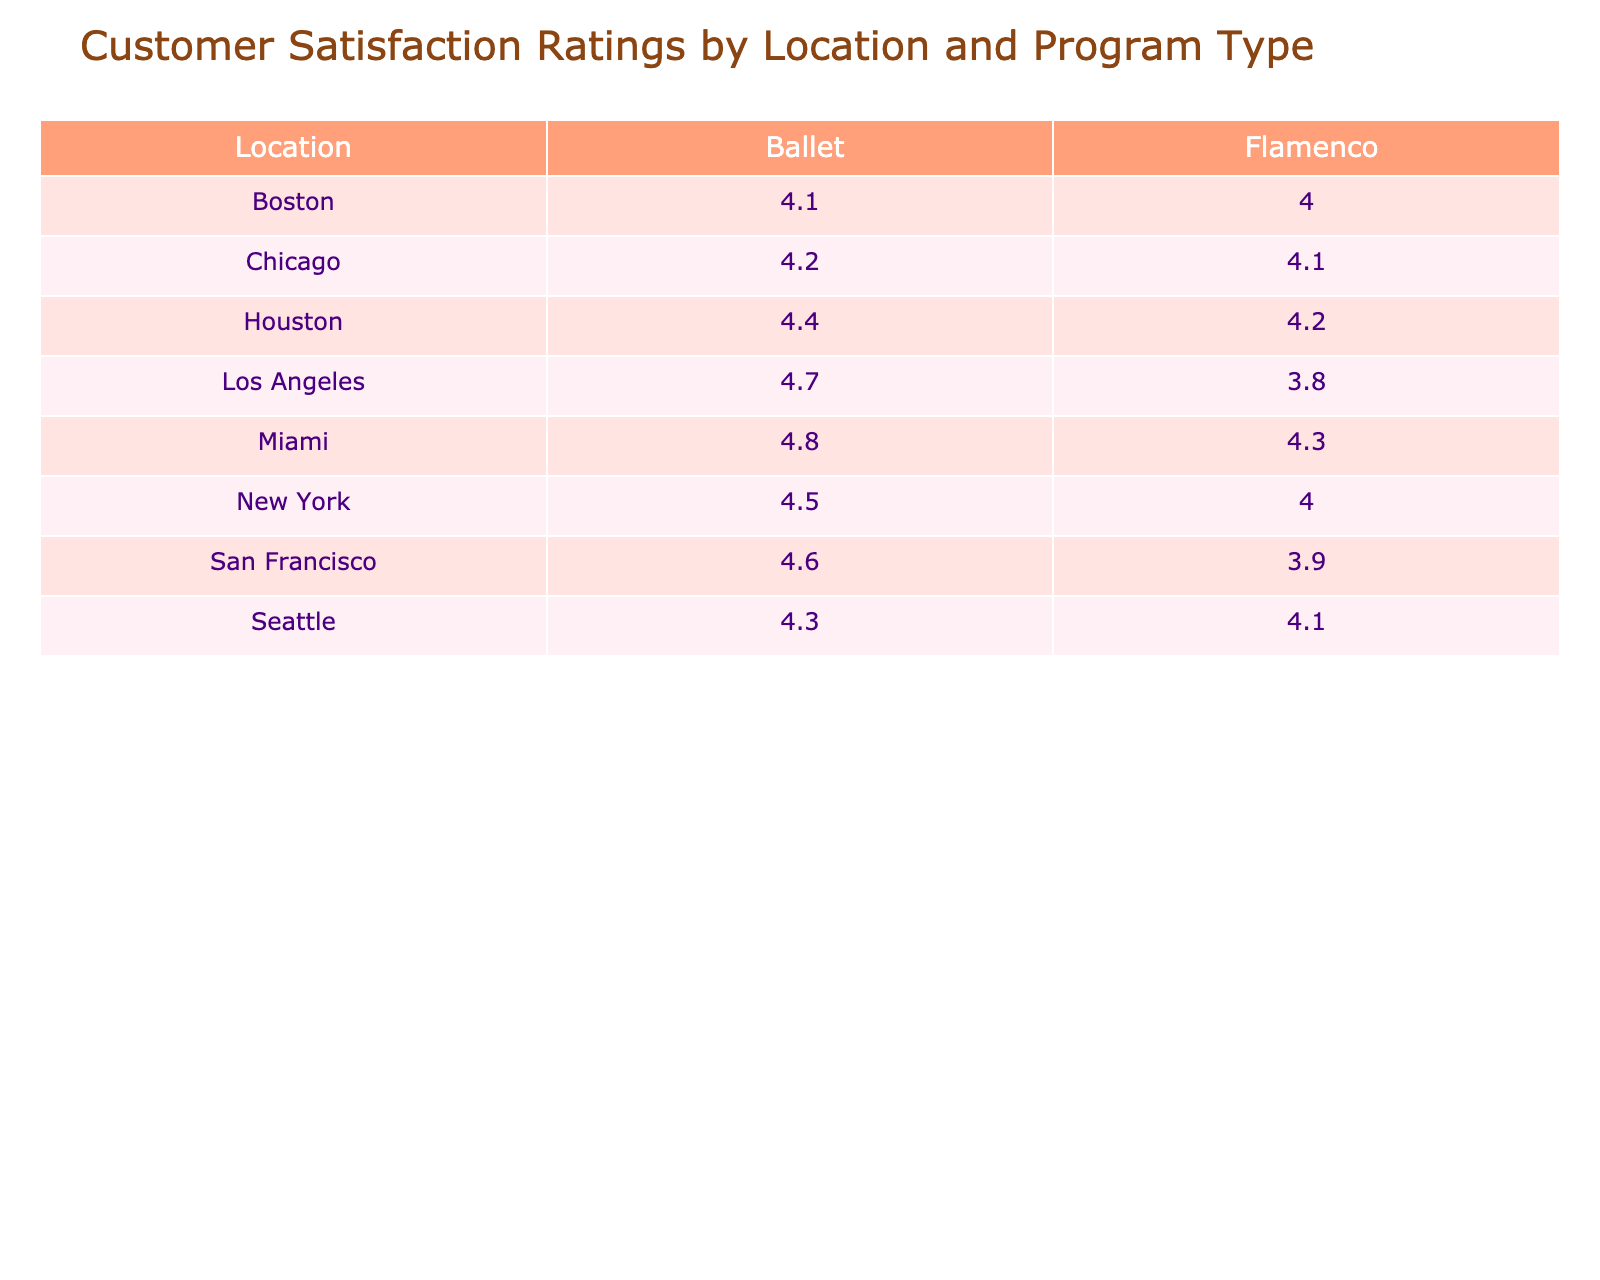What is the customer satisfaction rating for Ballet in Miami? The table shows that the customer satisfaction rating for the Ballet program in Miami is 4.8.
Answer: 4.8 Which location has the highest customer satisfaction rating for Flamenco? By looking at the Flamenco ratings, Miami has the highest rating of 4.3 among the locations listed.
Answer: Miami What is the average customer satisfaction rating for Ballet across all locations? To find the average for Ballet, add the ratings: (4.5 + 4.7 + 4.2 + 4.8 + 4.6 + 4.4 + 4.1 + 4.3) = 33.6, and divide by the total locations (8), giving an average of 33.6 / 8 = 4.2.
Answer: 4.2 Is the customer satisfaction rating for Flamenco in San Francisco higher than in Houston? In San Francisco, the rating for Flamenco is 3.9, while in Houston, it is 4.2. Since 3.9 is not higher than 4.2, the answer is no.
Answer: No What is the difference between the highest and lowest customer satisfaction rating for Ballet? The highest rating for Ballet is 4.8 (Miami), and the lowest is 4.1 (Boston). Subtracting these gives 4.8 - 4.1 = 0.7.
Answer: 0.7 Which location has a higher customer satisfaction rating for Flamenco, Chicago or Los Angeles? The Flamenco rating for Chicago is 4.1, while for Los Angeles, it is 3.8. Therefore, Chicago has a higher rating compared to Los Angeles.
Answer: Chicago What is the total satisfaction rating for Ballet in New York and Los Angeles combined? The ratings for Ballet in New York and Los Angeles are 4.5 and 4.7, respectively. Adding these together gives 4.5 + 4.7 = 9.2.
Answer: 9.2 Is the satisfaction rating for Ballet in Houston less than that in Seattle? The ratings are 4.4 for Houston and 4.3 for Seattle. Since 4.4 is not less than 4.3, the answer is no.
Answer: No What is the lowest customer satisfaction rating for Flamenco across all locations? The lowest rating for Flamenco across the locations listed is 3.8, observed in Los Angeles.
Answer: 3.8 